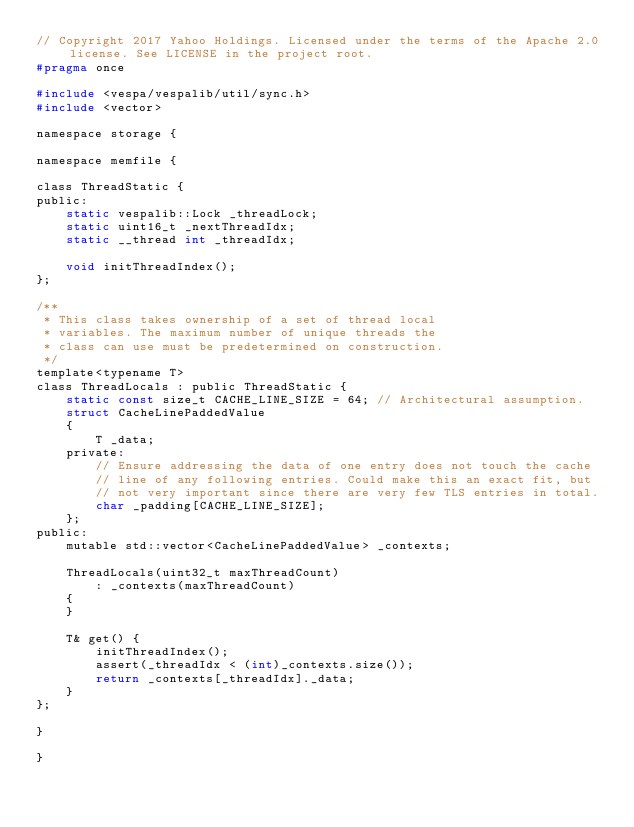<code> <loc_0><loc_0><loc_500><loc_500><_C_>// Copyright 2017 Yahoo Holdings. Licensed under the terms of the Apache 2.0 license. See LICENSE in the project root.
#pragma once

#include <vespa/vespalib/util/sync.h>
#include <vector>

namespace storage {

namespace memfile {

class ThreadStatic {
public:
    static vespalib::Lock _threadLock;
    static uint16_t _nextThreadIdx;
    static __thread int _threadIdx;

    void initThreadIndex();
};

/**
 * This class takes ownership of a set of thread local
 * variables. The maximum number of unique threads the
 * class can use must be predetermined on construction.
 */
template<typename T>
class ThreadLocals : public ThreadStatic {
    static const size_t CACHE_LINE_SIZE = 64; // Architectural assumption.
    struct CacheLinePaddedValue
    {
        T _data;
    private:
        // Ensure addressing the data of one entry does not touch the cache
        // line of any following entries. Could make this an exact fit, but
        // not very important since there are very few TLS entries in total.
        char _padding[CACHE_LINE_SIZE];
    };
public:
    mutable std::vector<CacheLinePaddedValue> _contexts;

    ThreadLocals(uint32_t maxThreadCount)
        : _contexts(maxThreadCount)
    {
    }

    T& get() {
        initThreadIndex();
        assert(_threadIdx < (int)_contexts.size());
        return _contexts[_threadIdx]._data;
    }
};

}

}

</code> 